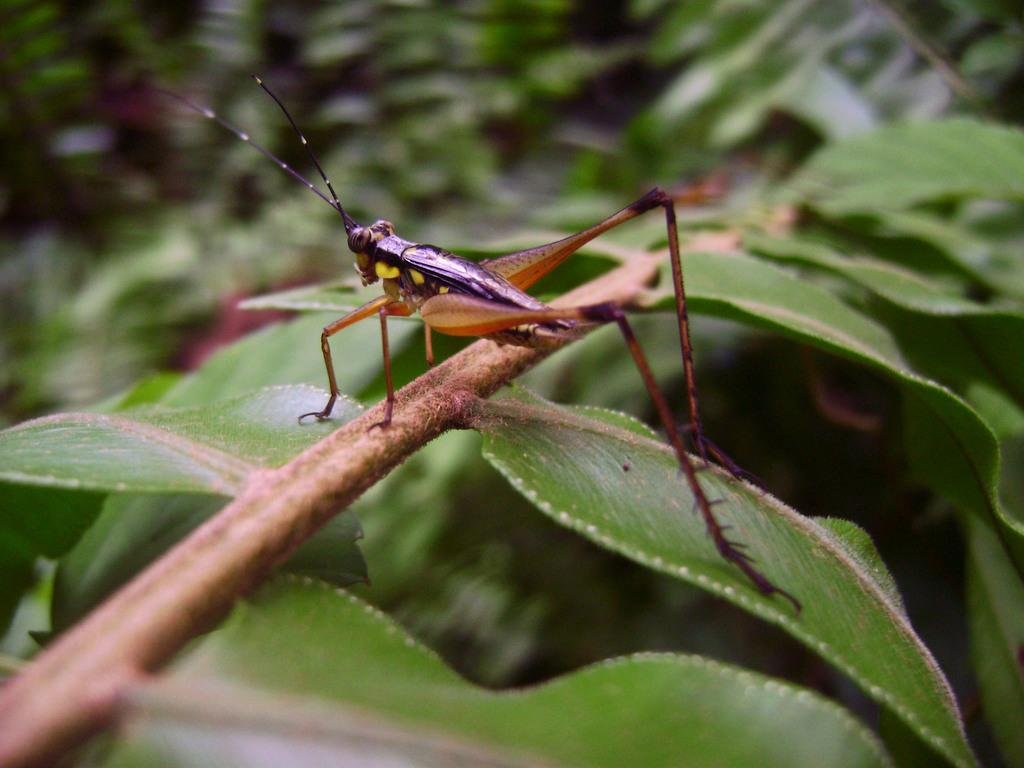What type of plant is visible in the image? There is a plant with leaves in the image. Are there any other living organisms present in the image? Yes, there is an insect with long legs in the image. Can you describe the background of the image? The background of the image contains many plants, but they are not clearly visible. What word is being distributed by the sea in the image? There is no sea or distribution of words present in the image. 